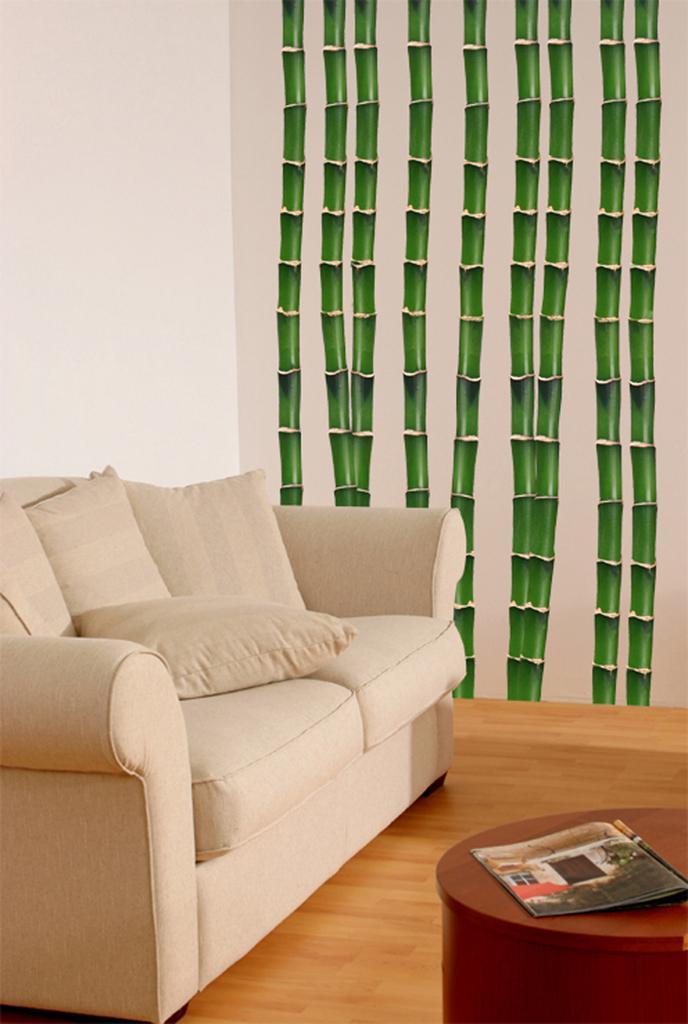Could you give a brief overview of what you see in this image? On the left It's a sofa there is a book on the table. 